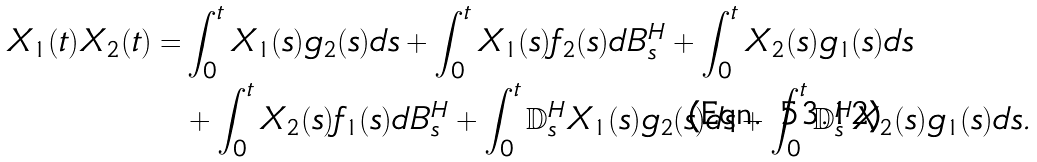<formula> <loc_0><loc_0><loc_500><loc_500>X _ { 1 } ( t ) X _ { 2 } ( t ) = & \int _ { 0 } ^ { t } X _ { 1 } ( s ) g _ { 2 } ( s ) d s + \int _ { 0 } ^ { t } X _ { 1 } ( s ) f _ { 2 } ( s ) d B _ { s } ^ { H } + \int _ { 0 } ^ { t } X _ { 2 } ( s ) g _ { 1 } ( s ) d s \\ & + \int _ { 0 } ^ { t } X _ { 2 } ( s ) f _ { 1 } ( s ) d B _ { s } ^ { H } + \int _ { 0 } ^ { t } \mathbb { D } _ { s } ^ { H } X _ { 1 } ( s ) g _ { 2 } ( s ) d s + \int _ { 0 } ^ { t } \mathbb { D } _ { s } ^ { H } X _ { 2 } ( s ) g _ { 1 } ( s ) d s .</formula> 